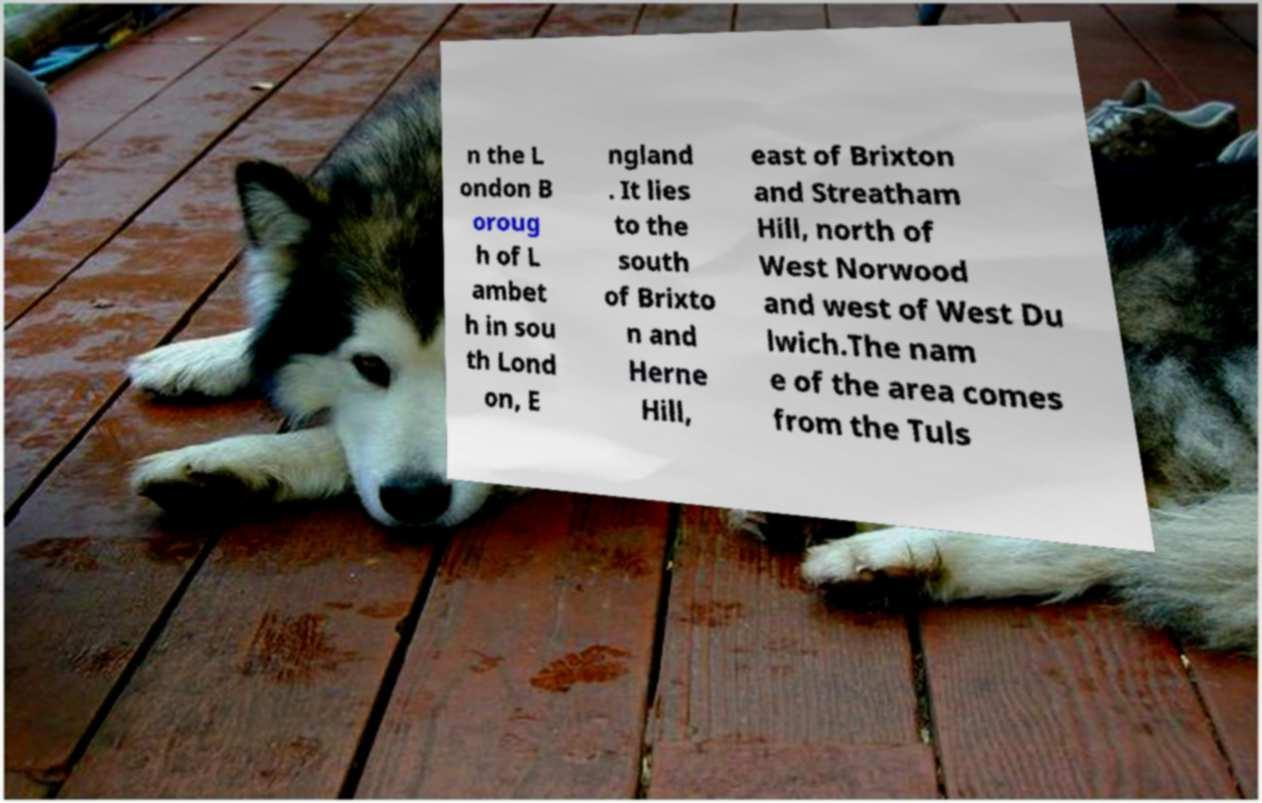Please identify and transcribe the text found in this image. n the L ondon B oroug h of L ambet h in sou th Lond on, E ngland . It lies to the south of Brixto n and Herne Hill, east of Brixton and Streatham Hill, north of West Norwood and west of West Du lwich.The nam e of the area comes from the Tuls 